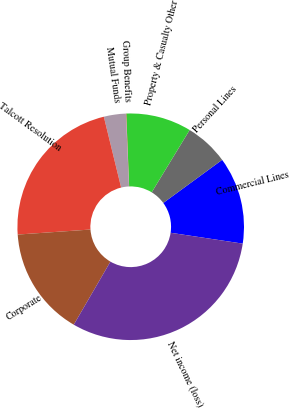<chart> <loc_0><loc_0><loc_500><loc_500><pie_chart><fcel>Commercial Lines<fcel>Personal Lines<fcel>Property & Casualty Other<fcel>Group Benefits<fcel>Mutual Funds<fcel>Talcott Resolution<fcel>Corporate<fcel>Net income (loss)<nl><fcel>12.43%<fcel>6.24%<fcel>9.33%<fcel>0.05%<fcel>3.14%<fcel>22.28%<fcel>15.52%<fcel>31.0%<nl></chart> 